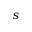Convert formula to latex. <formula><loc_0><loc_0><loc_500><loc_500>s</formula> 